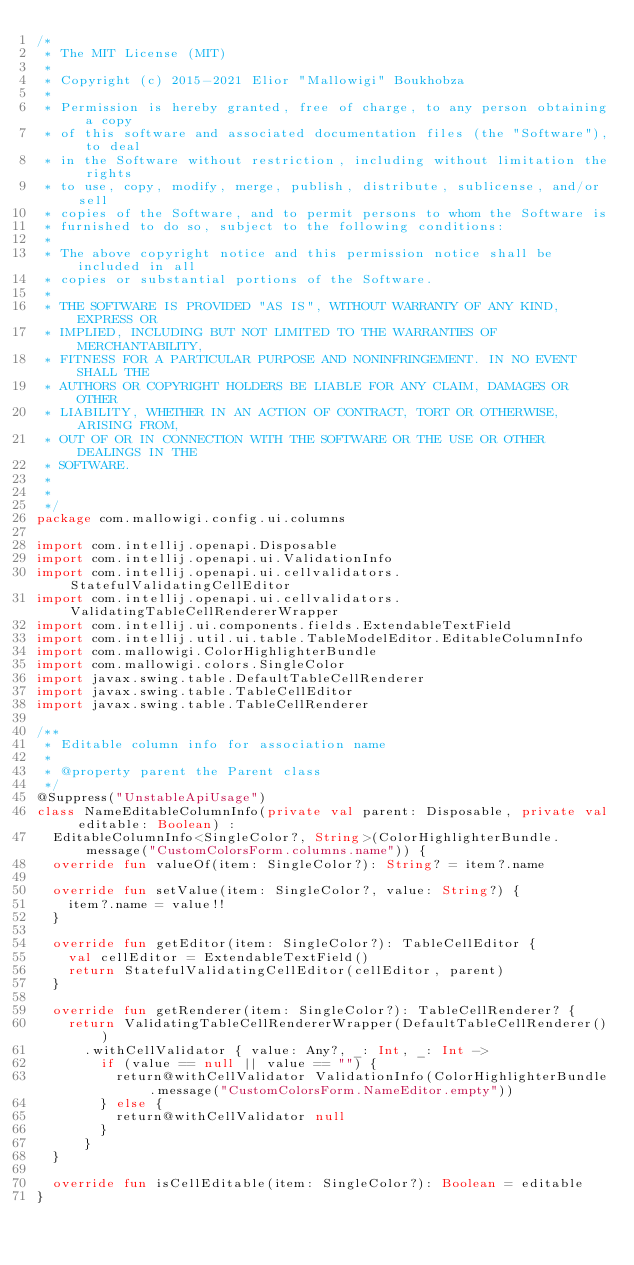<code> <loc_0><loc_0><loc_500><loc_500><_Kotlin_>/*
 * The MIT License (MIT)
 *
 * Copyright (c) 2015-2021 Elior "Mallowigi" Boukhobza
 *
 * Permission is hereby granted, free of charge, to any person obtaining a copy
 * of this software and associated documentation files (the "Software"), to deal
 * in the Software without restriction, including without limitation the rights
 * to use, copy, modify, merge, publish, distribute, sublicense, and/or sell
 * copies of the Software, and to permit persons to whom the Software is
 * furnished to do so, subject to the following conditions:
 *
 * The above copyright notice and this permission notice shall be included in all
 * copies or substantial portions of the Software.
 *
 * THE SOFTWARE IS PROVIDED "AS IS", WITHOUT WARRANTY OF ANY KIND, EXPRESS OR
 * IMPLIED, INCLUDING BUT NOT LIMITED TO THE WARRANTIES OF MERCHANTABILITY,
 * FITNESS FOR A PARTICULAR PURPOSE AND NONINFRINGEMENT. IN NO EVENT SHALL THE
 * AUTHORS OR COPYRIGHT HOLDERS BE LIABLE FOR ANY CLAIM, DAMAGES OR OTHER
 * LIABILITY, WHETHER IN AN ACTION OF CONTRACT, TORT OR OTHERWISE, ARISING FROM,
 * OUT OF OR IN CONNECTION WITH THE SOFTWARE OR THE USE OR OTHER DEALINGS IN THE
 * SOFTWARE.
 *
 *
 */
package com.mallowigi.config.ui.columns

import com.intellij.openapi.Disposable
import com.intellij.openapi.ui.ValidationInfo
import com.intellij.openapi.ui.cellvalidators.StatefulValidatingCellEditor
import com.intellij.openapi.ui.cellvalidators.ValidatingTableCellRendererWrapper
import com.intellij.ui.components.fields.ExtendableTextField
import com.intellij.util.ui.table.TableModelEditor.EditableColumnInfo
import com.mallowigi.ColorHighlighterBundle
import com.mallowigi.colors.SingleColor
import javax.swing.table.DefaultTableCellRenderer
import javax.swing.table.TableCellEditor
import javax.swing.table.TableCellRenderer

/**
 * Editable column info for association name
 *
 * @property parent the Parent class
 */
@Suppress("UnstableApiUsage")
class NameEditableColumnInfo(private val parent: Disposable, private val editable: Boolean) :
  EditableColumnInfo<SingleColor?, String>(ColorHighlighterBundle.message("CustomColorsForm.columns.name")) {
  override fun valueOf(item: SingleColor?): String? = item?.name

  override fun setValue(item: SingleColor?, value: String?) {
    item?.name = value!!
  }

  override fun getEditor(item: SingleColor?): TableCellEditor {
    val cellEditor = ExtendableTextField()
    return StatefulValidatingCellEditor(cellEditor, parent)
  }

  override fun getRenderer(item: SingleColor?): TableCellRenderer? {
    return ValidatingTableCellRendererWrapper(DefaultTableCellRenderer())
      .withCellValidator { value: Any?, _: Int, _: Int ->
        if (value == null || value == "") {
          return@withCellValidator ValidationInfo(ColorHighlighterBundle.message("CustomColorsForm.NameEditor.empty"))
        } else {
          return@withCellValidator null
        }
      }
  }

  override fun isCellEditable(item: SingleColor?): Boolean = editable
}
</code> 